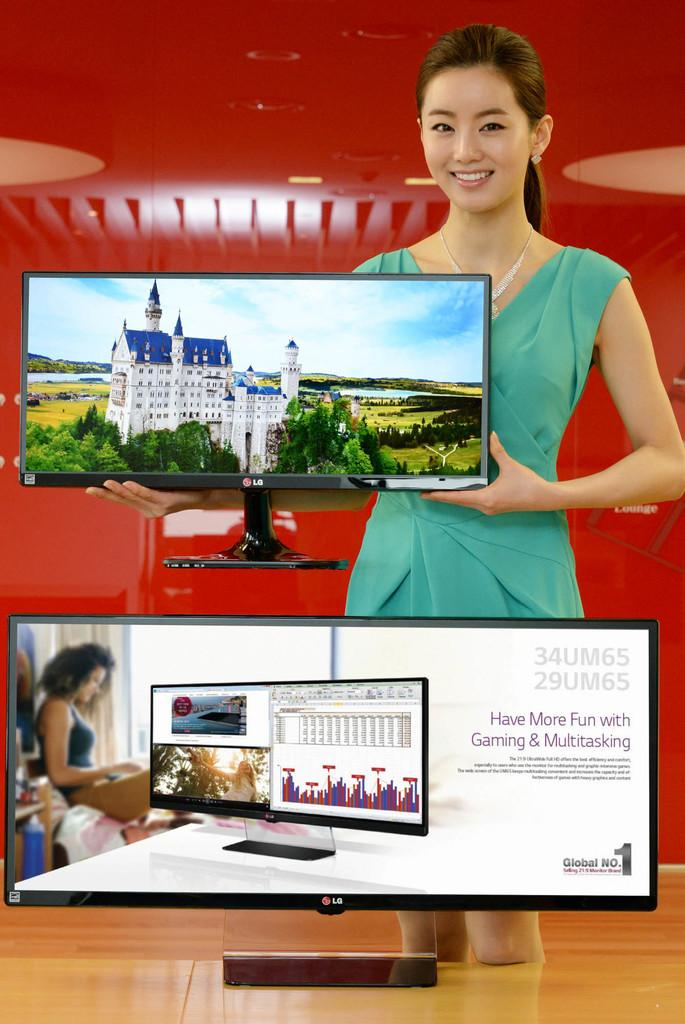<image>
Describe the image concisely. A woman holds an LG flat screen TV above another LG TV that displays the message "Have More Fun with Gaming & Multitasking". 